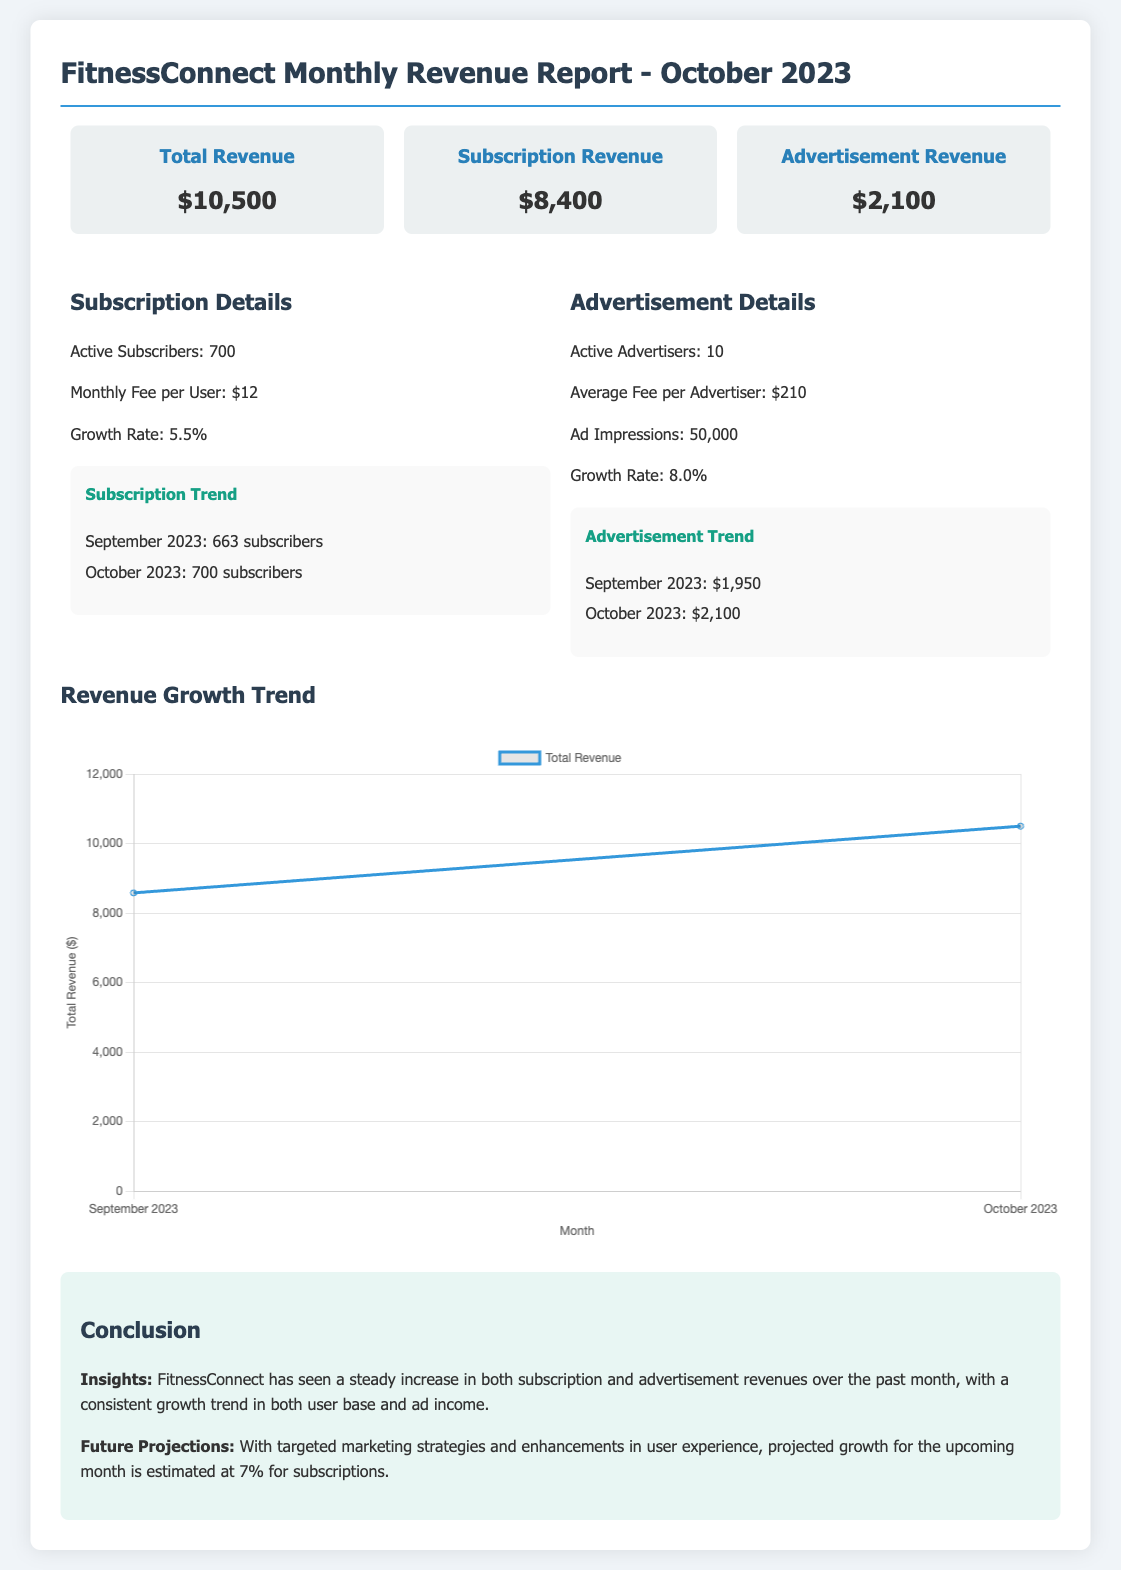What is the total revenue? The total revenue is presented as the overall revenue generated by the application, which is $10,500.
Answer: $10,500 How much is the subscription revenue? The subscription revenue is specifically detailed in the report and amounts to $8,400.
Answer: $8,400 What was the Active Subscriber count in October 2023? The document reveals that there were 700 active subscribers in October 2023.
Answer: 700 What was the advertisement revenue in October 2023? The advertisement revenue as stated in the report is $2,100.
Answer: $2,100 What is the growth rate of subscriptions? The report indicates a growth rate of 5.5% for the subscriptions.
Answer: 5.5% How many active advertisers are there? The report states that there are 10 active advertisers participating in the platform.
Answer: 10 What is the average fee per advertiser? It specifies that the average fee charged per advertiser is $210.
Answer: $210 In which month did the total revenue increase from $8,580 to $10,500? The increase in total revenue from $8,580 to $10,500 occurred between September 2023 and October 2023.
Answer: October 2023 What is the conclusion regarding the revenue trends? The conclusion indicates that there has been a steady increase in revenues over the past month.
Answer: Steady increase 